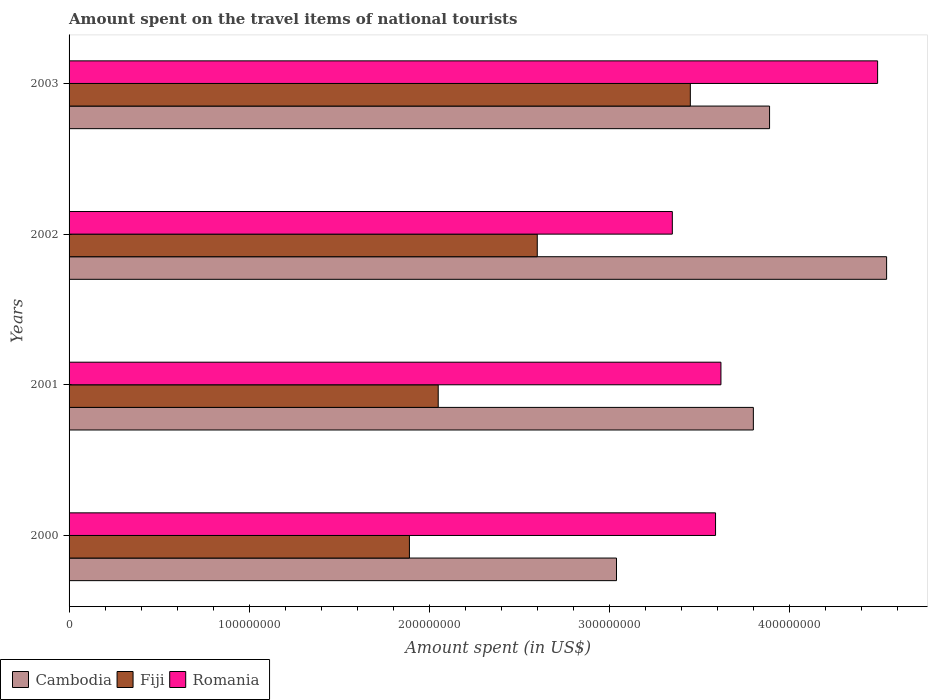Are the number of bars per tick equal to the number of legend labels?
Provide a short and direct response. Yes. What is the label of the 1st group of bars from the top?
Your response must be concise. 2003. In how many cases, is the number of bars for a given year not equal to the number of legend labels?
Offer a very short reply. 0. What is the amount spent on the travel items of national tourists in Fiji in 2001?
Your response must be concise. 2.05e+08. Across all years, what is the maximum amount spent on the travel items of national tourists in Cambodia?
Keep it short and to the point. 4.54e+08. Across all years, what is the minimum amount spent on the travel items of national tourists in Fiji?
Keep it short and to the point. 1.89e+08. What is the total amount spent on the travel items of national tourists in Romania in the graph?
Your answer should be very brief. 1.50e+09. What is the difference between the amount spent on the travel items of national tourists in Fiji in 2000 and that in 2001?
Give a very brief answer. -1.60e+07. What is the difference between the amount spent on the travel items of national tourists in Cambodia in 2000 and the amount spent on the travel items of national tourists in Romania in 2002?
Your answer should be compact. -3.10e+07. What is the average amount spent on the travel items of national tourists in Romania per year?
Offer a very short reply. 3.76e+08. In the year 2000, what is the difference between the amount spent on the travel items of national tourists in Fiji and amount spent on the travel items of national tourists in Cambodia?
Keep it short and to the point. -1.15e+08. What is the ratio of the amount spent on the travel items of national tourists in Romania in 2000 to that in 2001?
Give a very brief answer. 0.99. What is the difference between the highest and the second highest amount spent on the travel items of national tourists in Romania?
Keep it short and to the point. 8.70e+07. What is the difference between the highest and the lowest amount spent on the travel items of national tourists in Romania?
Your answer should be compact. 1.14e+08. What does the 1st bar from the top in 2003 represents?
Keep it short and to the point. Romania. What does the 2nd bar from the bottom in 2000 represents?
Provide a short and direct response. Fiji. Are all the bars in the graph horizontal?
Your answer should be compact. Yes. How many years are there in the graph?
Make the answer very short. 4. What is the difference between two consecutive major ticks on the X-axis?
Give a very brief answer. 1.00e+08. Does the graph contain grids?
Offer a very short reply. No. How are the legend labels stacked?
Your answer should be very brief. Horizontal. What is the title of the graph?
Give a very brief answer. Amount spent on the travel items of national tourists. What is the label or title of the X-axis?
Provide a succinct answer. Amount spent (in US$). What is the label or title of the Y-axis?
Give a very brief answer. Years. What is the Amount spent (in US$) in Cambodia in 2000?
Your response must be concise. 3.04e+08. What is the Amount spent (in US$) of Fiji in 2000?
Give a very brief answer. 1.89e+08. What is the Amount spent (in US$) of Romania in 2000?
Offer a very short reply. 3.59e+08. What is the Amount spent (in US$) in Cambodia in 2001?
Offer a terse response. 3.80e+08. What is the Amount spent (in US$) in Fiji in 2001?
Provide a short and direct response. 2.05e+08. What is the Amount spent (in US$) of Romania in 2001?
Give a very brief answer. 3.62e+08. What is the Amount spent (in US$) of Cambodia in 2002?
Your answer should be very brief. 4.54e+08. What is the Amount spent (in US$) in Fiji in 2002?
Ensure brevity in your answer.  2.60e+08. What is the Amount spent (in US$) in Romania in 2002?
Your answer should be very brief. 3.35e+08. What is the Amount spent (in US$) in Cambodia in 2003?
Provide a succinct answer. 3.89e+08. What is the Amount spent (in US$) in Fiji in 2003?
Your answer should be very brief. 3.45e+08. What is the Amount spent (in US$) in Romania in 2003?
Offer a terse response. 4.49e+08. Across all years, what is the maximum Amount spent (in US$) of Cambodia?
Offer a very short reply. 4.54e+08. Across all years, what is the maximum Amount spent (in US$) of Fiji?
Ensure brevity in your answer.  3.45e+08. Across all years, what is the maximum Amount spent (in US$) in Romania?
Ensure brevity in your answer.  4.49e+08. Across all years, what is the minimum Amount spent (in US$) in Cambodia?
Provide a succinct answer. 3.04e+08. Across all years, what is the minimum Amount spent (in US$) of Fiji?
Provide a short and direct response. 1.89e+08. Across all years, what is the minimum Amount spent (in US$) of Romania?
Provide a succinct answer. 3.35e+08. What is the total Amount spent (in US$) in Cambodia in the graph?
Your response must be concise. 1.53e+09. What is the total Amount spent (in US$) in Fiji in the graph?
Give a very brief answer. 9.99e+08. What is the total Amount spent (in US$) of Romania in the graph?
Your response must be concise. 1.50e+09. What is the difference between the Amount spent (in US$) in Cambodia in 2000 and that in 2001?
Offer a terse response. -7.60e+07. What is the difference between the Amount spent (in US$) in Fiji in 2000 and that in 2001?
Your response must be concise. -1.60e+07. What is the difference between the Amount spent (in US$) of Cambodia in 2000 and that in 2002?
Ensure brevity in your answer.  -1.50e+08. What is the difference between the Amount spent (in US$) in Fiji in 2000 and that in 2002?
Give a very brief answer. -7.10e+07. What is the difference between the Amount spent (in US$) in Romania in 2000 and that in 2002?
Your response must be concise. 2.40e+07. What is the difference between the Amount spent (in US$) in Cambodia in 2000 and that in 2003?
Make the answer very short. -8.50e+07. What is the difference between the Amount spent (in US$) in Fiji in 2000 and that in 2003?
Your response must be concise. -1.56e+08. What is the difference between the Amount spent (in US$) in Romania in 2000 and that in 2003?
Ensure brevity in your answer.  -9.00e+07. What is the difference between the Amount spent (in US$) of Cambodia in 2001 and that in 2002?
Offer a very short reply. -7.40e+07. What is the difference between the Amount spent (in US$) in Fiji in 2001 and that in 2002?
Give a very brief answer. -5.50e+07. What is the difference between the Amount spent (in US$) in Romania in 2001 and that in 2002?
Your answer should be compact. 2.70e+07. What is the difference between the Amount spent (in US$) of Cambodia in 2001 and that in 2003?
Offer a terse response. -9.00e+06. What is the difference between the Amount spent (in US$) in Fiji in 2001 and that in 2003?
Offer a very short reply. -1.40e+08. What is the difference between the Amount spent (in US$) in Romania in 2001 and that in 2003?
Make the answer very short. -8.70e+07. What is the difference between the Amount spent (in US$) in Cambodia in 2002 and that in 2003?
Ensure brevity in your answer.  6.50e+07. What is the difference between the Amount spent (in US$) of Fiji in 2002 and that in 2003?
Your answer should be very brief. -8.50e+07. What is the difference between the Amount spent (in US$) in Romania in 2002 and that in 2003?
Make the answer very short. -1.14e+08. What is the difference between the Amount spent (in US$) in Cambodia in 2000 and the Amount spent (in US$) in Fiji in 2001?
Make the answer very short. 9.90e+07. What is the difference between the Amount spent (in US$) in Cambodia in 2000 and the Amount spent (in US$) in Romania in 2001?
Your answer should be compact. -5.80e+07. What is the difference between the Amount spent (in US$) in Fiji in 2000 and the Amount spent (in US$) in Romania in 2001?
Offer a terse response. -1.73e+08. What is the difference between the Amount spent (in US$) in Cambodia in 2000 and the Amount spent (in US$) in Fiji in 2002?
Provide a short and direct response. 4.40e+07. What is the difference between the Amount spent (in US$) in Cambodia in 2000 and the Amount spent (in US$) in Romania in 2002?
Your answer should be compact. -3.10e+07. What is the difference between the Amount spent (in US$) in Fiji in 2000 and the Amount spent (in US$) in Romania in 2002?
Provide a short and direct response. -1.46e+08. What is the difference between the Amount spent (in US$) in Cambodia in 2000 and the Amount spent (in US$) in Fiji in 2003?
Keep it short and to the point. -4.10e+07. What is the difference between the Amount spent (in US$) of Cambodia in 2000 and the Amount spent (in US$) of Romania in 2003?
Keep it short and to the point. -1.45e+08. What is the difference between the Amount spent (in US$) of Fiji in 2000 and the Amount spent (in US$) of Romania in 2003?
Offer a terse response. -2.60e+08. What is the difference between the Amount spent (in US$) of Cambodia in 2001 and the Amount spent (in US$) of Fiji in 2002?
Ensure brevity in your answer.  1.20e+08. What is the difference between the Amount spent (in US$) in Cambodia in 2001 and the Amount spent (in US$) in Romania in 2002?
Offer a terse response. 4.50e+07. What is the difference between the Amount spent (in US$) of Fiji in 2001 and the Amount spent (in US$) of Romania in 2002?
Offer a very short reply. -1.30e+08. What is the difference between the Amount spent (in US$) in Cambodia in 2001 and the Amount spent (in US$) in Fiji in 2003?
Keep it short and to the point. 3.50e+07. What is the difference between the Amount spent (in US$) of Cambodia in 2001 and the Amount spent (in US$) of Romania in 2003?
Make the answer very short. -6.90e+07. What is the difference between the Amount spent (in US$) of Fiji in 2001 and the Amount spent (in US$) of Romania in 2003?
Make the answer very short. -2.44e+08. What is the difference between the Amount spent (in US$) of Cambodia in 2002 and the Amount spent (in US$) of Fiji in 2003?
Your response must be concise. 1.09e+08. What is the difference between the Amount spent (in US$) in Cambodia in 2002 and the Amount spent (in US$) in Romania in 2003?
Offer a very short reply. 5.00e+06. What is the difference between the Amount spent (in US$) of Fiji in 2002 and the Amount spent (in US$) of Romania in 2003?
Make the answer very short. -1.89e+08. What is the average Amount spent (in US$) of Cambodia per year?
Provide a succinct answer. 3.82e+08. What is the average Amount spent (in US$) in Fiji per year?
Provide a short and direct response. 2.50e+08. What is the average Amount spent (in US$) in Romania per year?
Your answer should be compact. 3.76e+08. In the year 2000, what is the difference between the Amount spent (in US$) of Cambodia and Amount spent (in US$) of Fiji?
Your answer should be very brief. 1.15e+08. In the year 2000, what is the difference between the Amount spent (in US$) of Cambodia and Amount spent (in US$) of Romania?
Make the answer very short. -5.50e+07. In the year 2000, what is the difference between the Amount spent (in US$) in Fiji and Amount spent (in US$) in Romania?
Your answer should be very brief. -1.70e+08. In the year 2001, what is the difference between the Amount spent (in US$) in Cambodia and Amount spent (in US$) in Fiji?
Your response must be concise. 1.75e+08. In the year 2001, what is the difference between the Amount spent (in US$) of Cambodia and Amount spent (in US$) of Romania?
Your response must be concise. 1.80e+07. In the year 2001, what is the difference between the Amount spent (in US$) of Fiji and Amount spent (in US$) of Romania?
Your answer should be compact. -1.57e+08. In the year 2002, what is the difference between the Amount spent (in US$) in Cambodia and Amount spent (in US$) in Fiji?
Give a very brief answer. 1.94e+08. In the year 2002, what is the difference between the Amount spent (in US$) of Cambodia and Amount spent (in US$) of Romania?
Keep it short and to the point. 1.19e+08. In the year 2002, what is the difference between the Amount spent (in US$) in Fiji and Amount spent (in US$) in Romania?
Keep it short and to the point. -7.50e+07. In the year 2003, what is the difference between the Amount spent (in US$) of Cambodia and Amount spent (in US$) of Fiji?
Make the answer very short. 4.40e+07. In the year 2003, what is the difference between the Amount spent (in US$) in Cambodia and Amount spent (in US$) in Romania?
Keep it short and to the point. -6.00e+07. In the year 2003, what is the difference between the Amount spent (in US$) in Fiji and Amount spent (in US$) in Romania?
Make the answer very short. -1.04e+08. What is the ratio of the Amount spent (in US$) in Fiji in 2000 to that in 2001?
Your answer should be very brief. 0.92. What is the ratio of the Amount spent (in US$) of Romania in 2000 to that in 2001?
Offer a terse response. 0.99. What is the ratio of the Amount spent (in US$) of Cambodia in 2000 to that in 2002?
Provide a short and direct response. 0.67. What is the ratio of the Amount spent (in US$) of Fiji in 2000 to that in 2002?
Give a very brief answer. 0.73. What is the ratio of the Amount spent (in US$) in Romania in 2000 to that in 2002?
Give a very brief answer. 1.07. What is the ratio of the Amount spent (in US$) in Cambodia in 2000 to that in 2003?
Keep it short and to the point. 0.78. What is the ratio of the Amount spent (in US$) in Fiji in 2000 to that in 2003?
Give a very brief answer. 0.55. What is the ratio of the Amount spent (in US$) of Romania in 2000 to that in 2003?
Make the answer very short. 0.8. What is the ratio of the Amount spent (in US$) of Cambodia in 2001 to that in 2002?
Offer a very short reply. 0.84. What is the ratio of the Amount spent (in US$) of Fiji in 2001 to that in 2002?
Make the answer very short. 0.79. What is the ratio of the Amount spent (in US$) in Romania in 2001 to that in 2002?
Offer a very short reply. 1.08. What is the ratio of the Amount spent (in US$) of Cambodia in 2001 to that in 2003?
Provide a succinct answer. 0.98. What is the ratio of the Amount spent (in US$) of Fiji in 2001 to that in 2003?
Your answer should be very brief. 0.59. What is the ratio of the Amount spent (in US$) of Romania in 2001 to that in 2003?
Make the answer very short. 0.81. What is the ratio of the Amount spent (in US$) of Cambodia in 2002 to that in 2003?
Your answer should be compact. 1.17. What is the ratio of the Amount spent (in US$) in Fiji in 2002 to that in 2003?
Offer a very short reply. 0.75. What is the ratio of the Amount spent (in US$) of Romania in 2002 to that in 2003?
Your answer should be very brief. 0.75. What is the difference between the highest and the second highest Amount spent (in US$) in Cambodia?
Give a very brief answer. 6.50e+07. What is the difference between the highest and the second highest Amount spent (in US$) of Fiji?
Offer a very short reply. 8.50e+07. What is the difference between the highest and the second highest Amount spent (in US$) in Romania?
Your response must be concise. 8.70e+07. What is the difference between the highest and the lowest Amount spent (in US$) of Cambodia?
Your response must be concise. 1.50e+08. What is the difference between the highest and the lowest Amount spent (in US$) of Fiji?
Ensure brevity in your answer.  1.56e+08. What is the difference between the highest and the lowest Amount spent (in US$) of Romania?
Keep it short and to the point. 1.14e+08. 